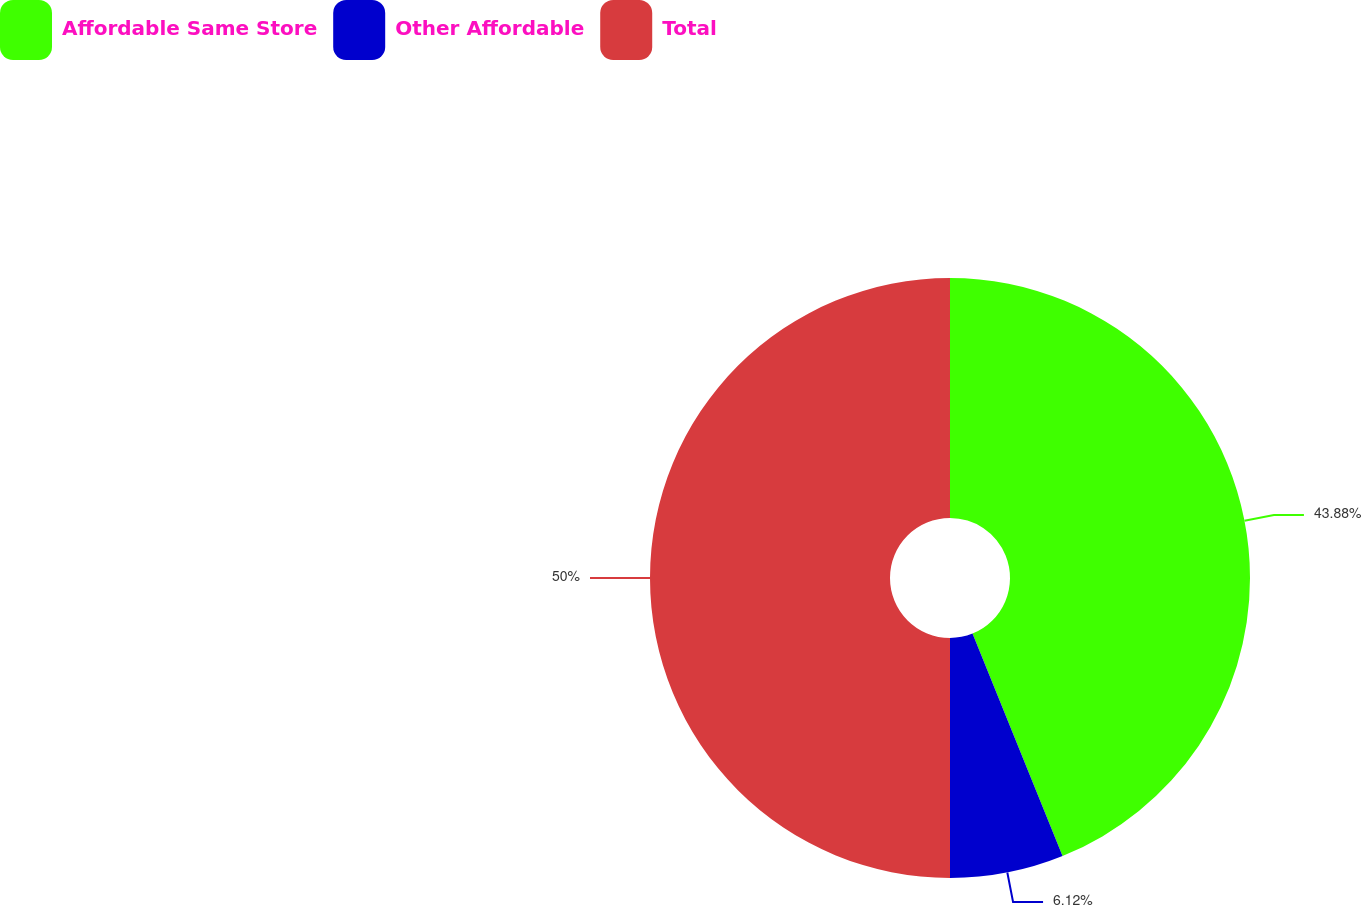Convert chart to OTSL. <chart><loc_0><loc_0><loc_500><loc_500><pie_chart><fcel>Affordable Same Store<fcel>Other Affordable<fcel>Total<nl><fcel>43.88%<fcel>6.12%<fcel>50.0%<nl></chart> 